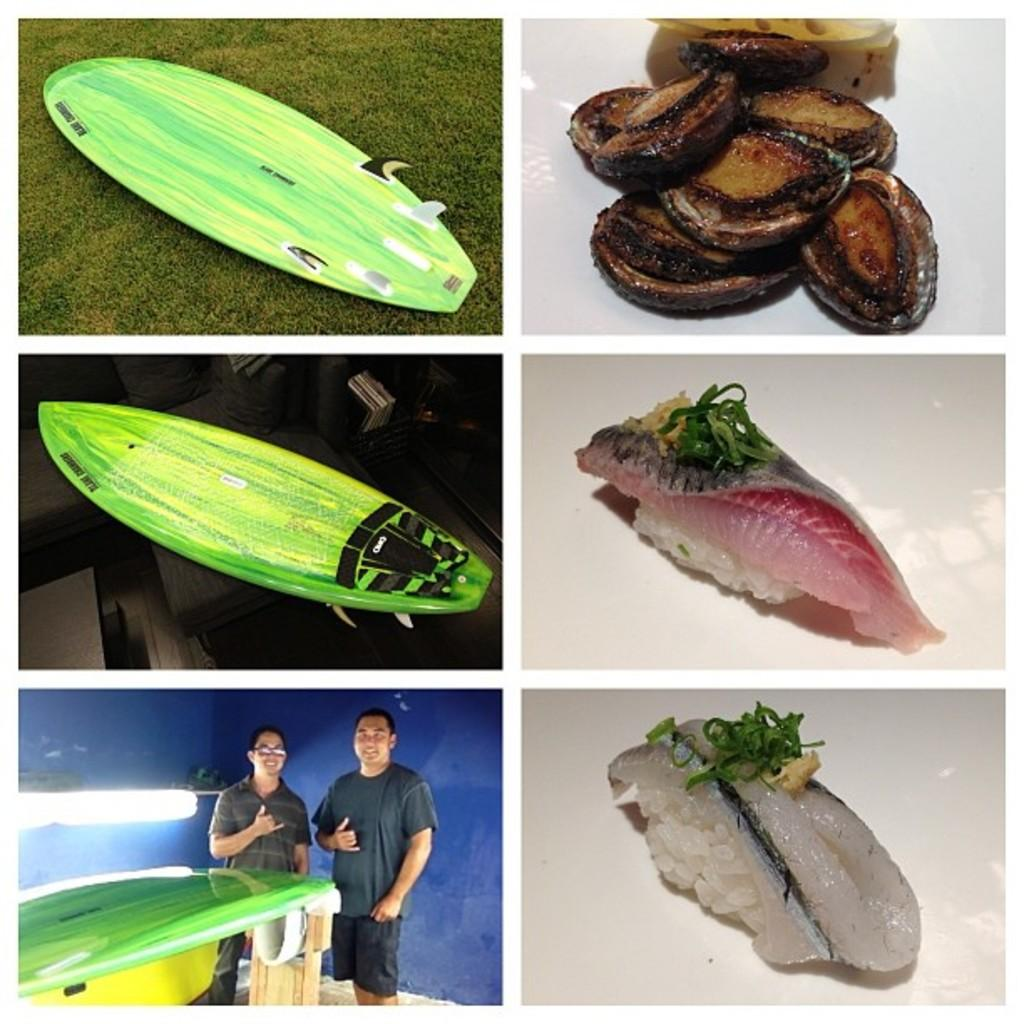How many people are present in the collage? There are two persons in the collage. What type of objects can be seen made of wood? There are wooden objects in the collage. What else is present in the collage besides the people and wooden objects? There are food items in the collage. What type of bird can be seen flying in the collage? There is no bird present in the collage; it only contains two persons, wooden objects, and food items. 